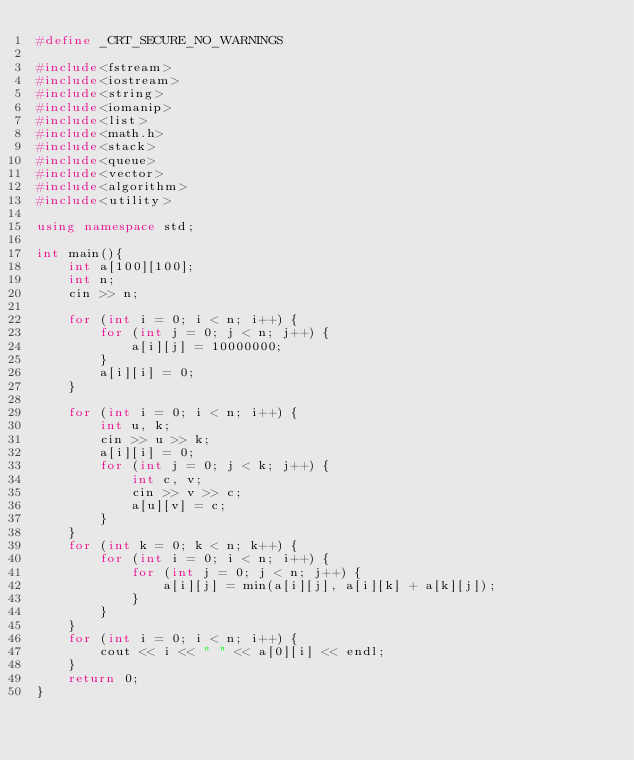<code> <loc_0><loc_0><loc_500><loc_500><_C++_>#define _CRT_SECURE_NO_WARNINGS

#include<fstream>
#include<iostream>
#include<string>
#include<iomanip>
#include<list>
#include<math.h>
#include<stack>
#include<queue>
#include<vector>
#include<algorithm>
#include<utility>

using namespace std;

int main(){
	int a[100][100];
	int n;
	cin >> n;

	for (int i = 0; i < n; i++) {
		for (int j = 0; j < n; j++) {
			a[i][j] = 10000000;
		}
		a[i][i] = 0;
	}

	for (int i = 0; i < n; i++) {
		int u, k;
		cin >> u >> k;
		a[i][i] = 0;
		for (int j = 0; j < k; j++) {
			int c, v;
			cin >> v >> c;
			a[u][v] = c;
		}
	}
	for (int k = 0; k < n; k++) {
		for (int i = 0; i < n; i++) {
			for (int j = 0; j < n; j++) {
				a[i][j] = min(a[i][j], a[i][k] + a[k][j]);
			}
		}
	}
	for (int i = 0; i < n; i++) {
		cout << i << " " << a[0][i] << endl;
	}
	return 0;
}</code> 